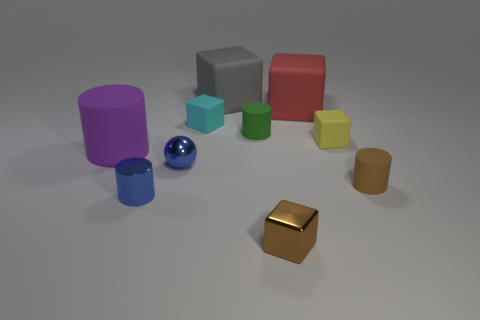Does the metal cylinder have the same color as the metal sphere?
Offer a terse response. Yes. What number of large red rubber blocks are there?
Offer a terse response. 1. There is a rubber cylinder to the right of the brown cube; does it have the same color as the cube that is in front of the blue ball?
Your response must be concise. Yes. There is a small blue cylinder; how many tiny yellow matte blocks are right of it?
Your response must be concise. 1. There is a thing that is the same color as the tiny metal block; what material is it?
Give a very brief answer. Rubber. Are there any small brown objects that have the same shape as the yellow object?
Your answer should be very brief. Yes. Do the big thing left of the gray rubber block and the tiny cylinder that is on the right side of the small yellow object have the same material?
Keep it short and to the point. Yes. What is the size of the gray matte block that is right of the tiny matte block that is left of the shiny object that is on the right side of the small cyan rubber thing?
Provide a succinct answer. Large. There is a blue cylinder that is the same size as the cyan thing; what is it made of?
Ensure brevity in your answer.  Metal. Is there a blue metal ball of the same size as the blue metallic cylinder?
Offer a very short reply. Yes. 